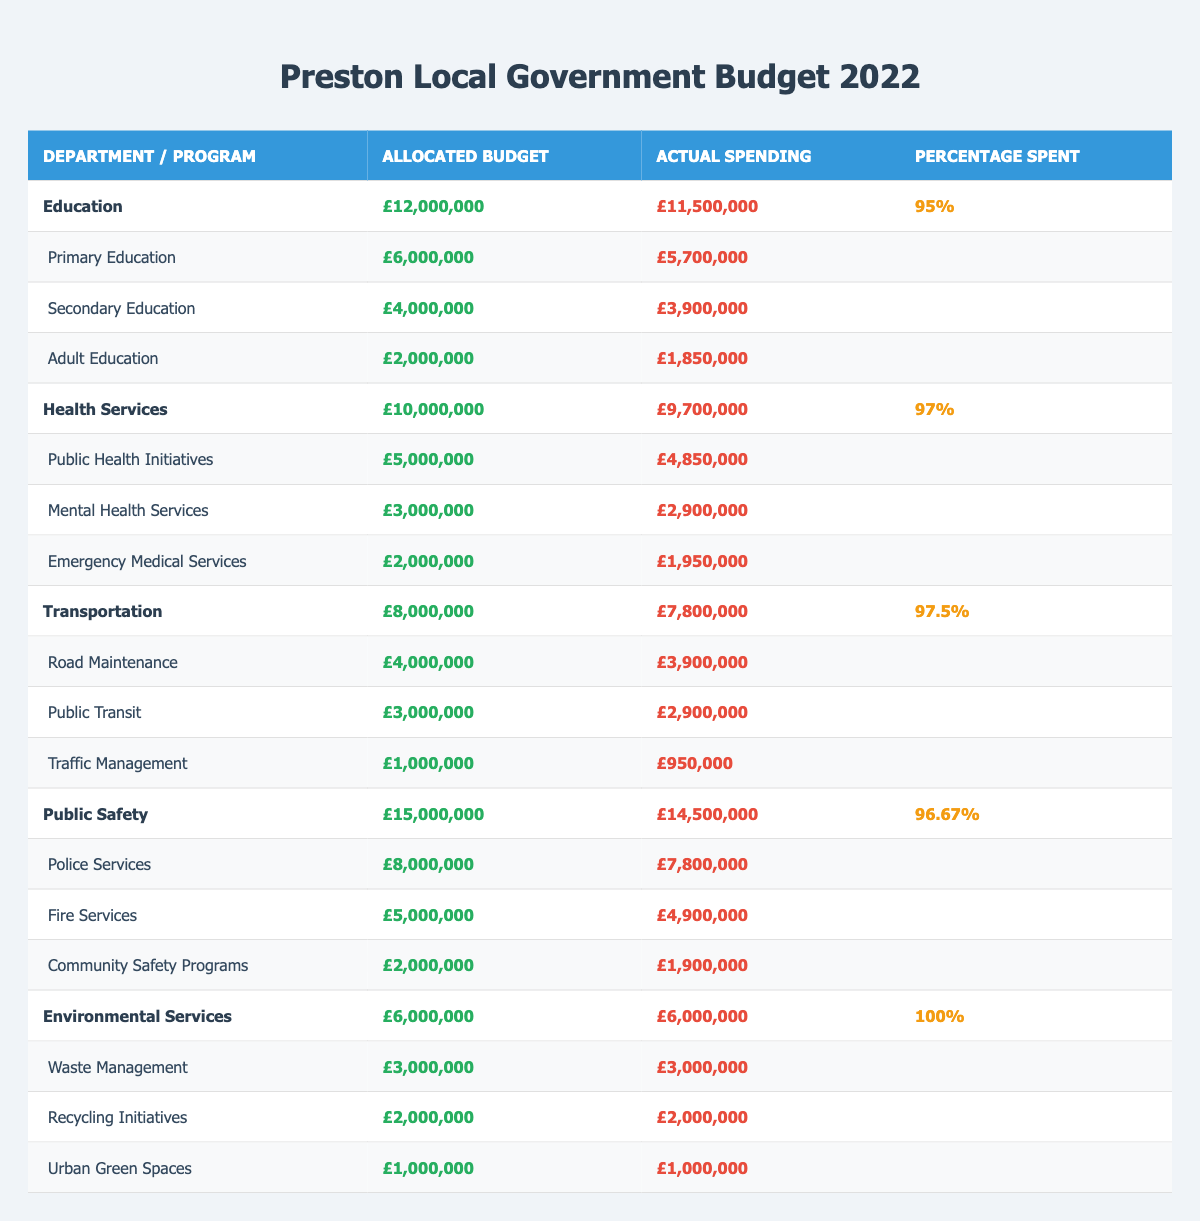What is the total allocated budget for Public Safety? The allocated budget for Public Safety is specifically listed in the table. It shows £15,000,000 for the department.
Answer: £15,000,000 How much was actually spent on Education? The actual spending on Education can be found in the corresponding row for the department, which indicates £11,500,000.
Answer: £11,500,000 What percentage of the Health Services budget was spent? To find this percentage, refer to the specific column under Health Services where it states that 97% of the allocated budget was spent.
Answer: 97% Which department had the lowest percentage spent relative to its allocated budget? By comparing the percentage spent across all departments, Education has the lowest at 95%.
Answer: Education What is the combined budget for all the programs under Transportation? The combined budget is calculated by adding the budgets of all programs under Transportation: £4,000,000 (Road Maintenance) + £3,000,000 (Public Transit) + £1,000,000 (Traffic Management) = £8,000,000.
Answer: £8,000,000 Did Environmental Services utilize their entire allocated budget? Yes, the table shows that Environmental Services had an allocated budget of £6,000,000 and actual spending of £6,000,000, indicating full utilization.
Answer: Yes What is the total amount spent on Public Safety programs? The total amount spent across Public Safety programs is calculated by summing the actual spending of each program: £7,800,000 (Police Services) + £4,900,000 (Fire Services) + £1,900,000 (Community Safety Programs) = £14,600,000.
Answer: £14,600,000 How much more was spent on Health Services compared to Transportation? The spending difference is calculated by subtracting the actual spending on Transportation (£7,800,000) from Health Services (£9,700,000): £9,700,000 - £7,800,000 = £1,900,000.
Answer: £1,900,000 What was the actual spending on Adult Education as a percentage of its allocated budget? The actual spending on Adult Education was £1,850,000 against an allocated budget of £2,000,000. The calculation is (£1,850,000 / £2,000,000) * 100 = 92.5%.
Answer: 92.5% Which department had the highest total actual spending? By reviewing the individual actual spending amounts, Public Safety had the highest total actual spending of £14,500,000.
Answer: Public Safety 